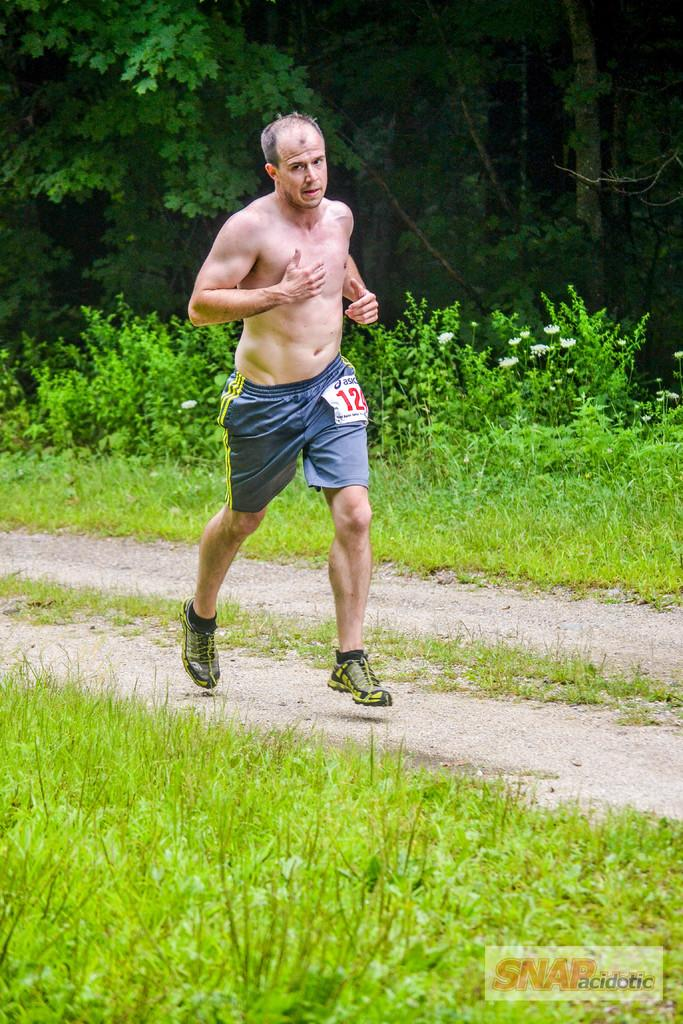<image>
Render a clear and concise summary of the photo. a person running with the number 12 on their shorts 